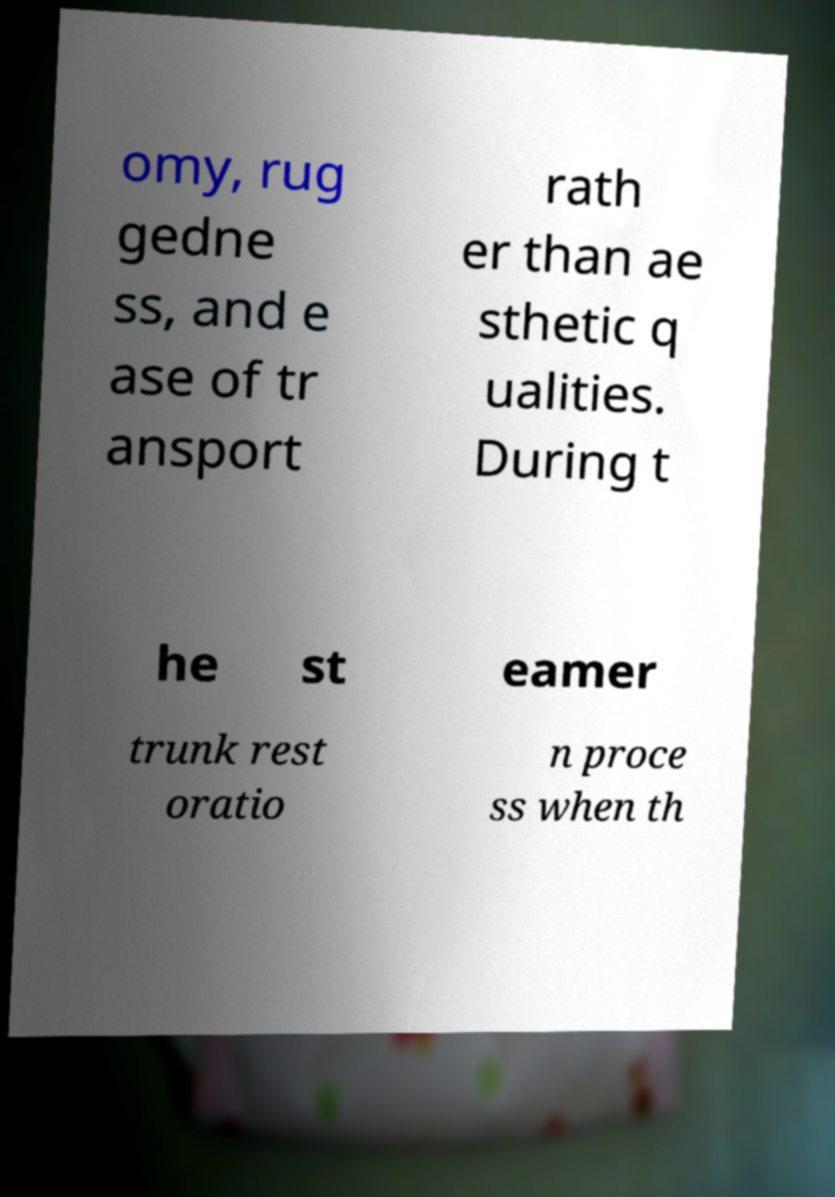Please identify and transcribe the text found in this image. omy, rug gedne ss, and e ase of tr ansport rath er than ae sthetic q ualities. During t he st eamer trunk rest oratio n proce ss when th 